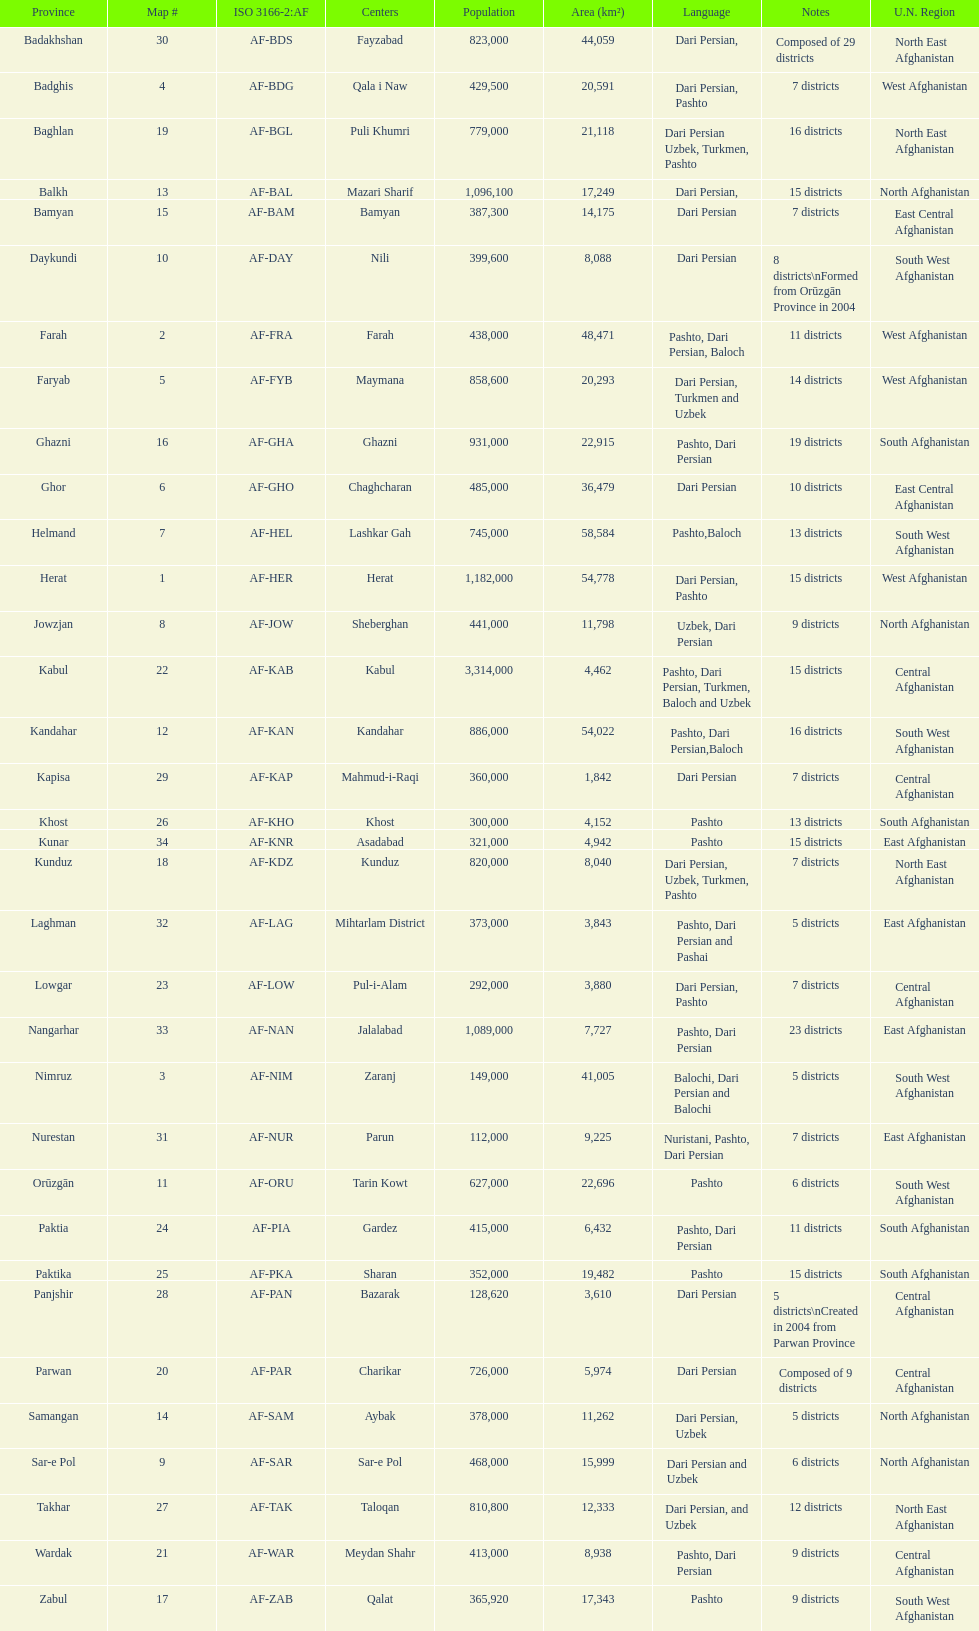Does ghor or farah have more districts? Farah. 